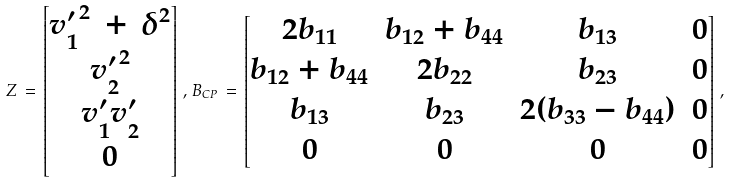Convert formula to latex. <formula><loc_0><loc_0><loc_500><loc_500>Z \, = \, \begin{bmatrix} { v ^ { \prime } _ { 1 } } ^ { 2 } \, + \, \delta ^ { 2 } \\ { v ^ { \prime } _ { 2 } } ^ { 2 } \\ v ^ { \prime } _ { 1 } v ^ { \prime } _ { 2 } \\ 0 \end{bmatrix} \, , \, B _ { C P } \, = \, \begin{bmatrix} 2 b _ { 1 1 } & b _ { 1 2 } + b _ { 4 4 } & b _ { 1 3 } & 0 \\ b _ { 1 2 } + b _ { 4 4 } & 2 b _ { 2 2 } & b _ { 2 3 } & 0 \\ b _ { 1 3 } & b _ { 2 3 } & 2 ( b _ { 3 3 } - b _ { 4 4 } ) & 0 \\ 0 & 0 & 0 & 0 \end{bmatrix} \, ,</formula> 